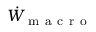<formula> <loc_0><loc_0><loc_500><loc_500>\dot { W } _ { m a c r o }</formula> 